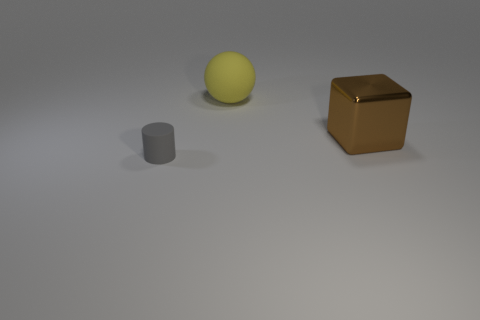Add 1 big red spheres. How many objects exist? 4 Subtract all blocks. How many objects are left? 2 Subtract 0 blue cylinders. How many objects are left? 3 Subtract all large brown things. Subtract all brown cubes. How many objects are left? 1 Add 1 spheres. How many spheres are left? 2 Add 3 large yellow objects. How many large yellow objects exist? 4 